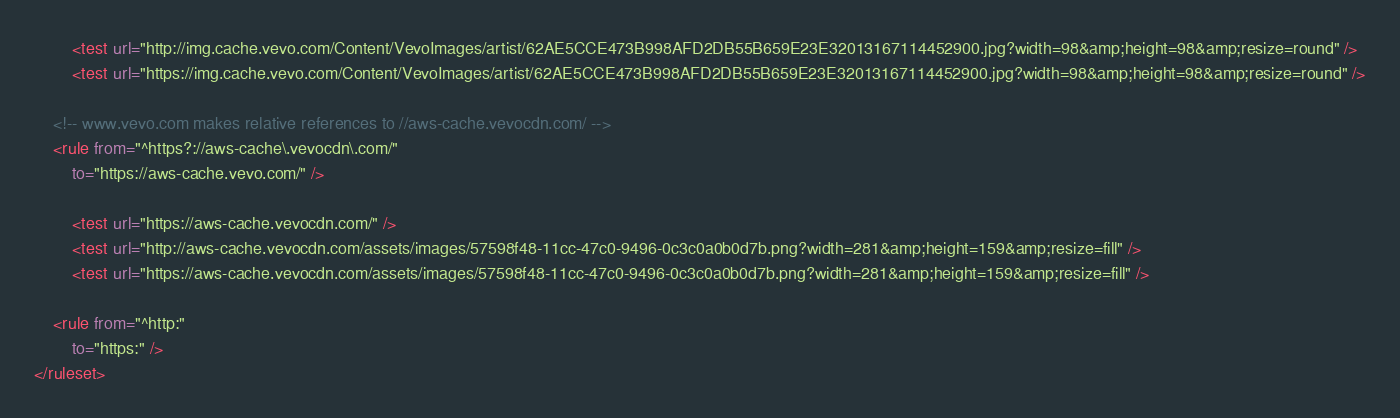<code> <loc_0><loc_0><loc_500><loc_500><_XML_>		<test url="http://img.cache.vevo.com/Content/VevoImages/artist/62AE5CCE473B998AFD2DB55B659E23E32013167114452900.jpg?width=98&amp;height=98&amp;resize=round" />
		<test url="https://img.cache.vevo.com/Content/VevoImages/artist/62AE5CCE473B998AFD2DB55B659E23E32013167114452900.jpg?width=98&amp;height=98&amp;resize=round" />

	<!-- www.vevo.com makes relative references to //aws-cache.vevocdn.com/ -->
	<rule from="^https?://aws-cache\.vevocdn\.com/"
		to="https://aws-cache.vevo.com/" />

		<test url="https://aws-cache.vevocdn.com/" />
		<test url="http://aws-cache.vevocdn.com/assets/images/57598f48-11cc-47c0-9496-0c3c0a0b0d7b.png?width=281&amp;height=159&amp;resize=fill" />
		<test url="https://aws-cache.vevocdn.com/assets/images/57598f48-11cc-47c0-9496-0c3c0a0b0d7b.png?width=281&amp;height=159&amp;resize=fill" />

	<rule from="^http:"
		to="https:" />
</ruleset>
</code> 